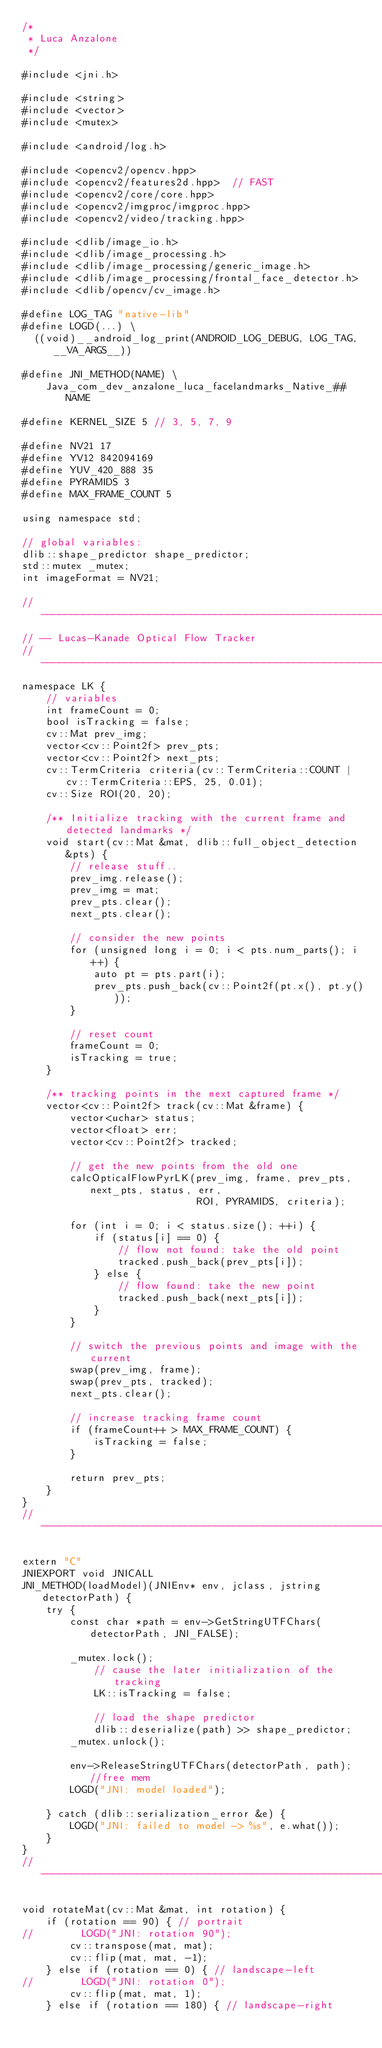Convert code to text. <code><loc_0><loc_0><loc_500><loc_500><_C++_>/*
 * Luca Anzalone
 */

#include <jni.h>

#include <string>
#include <vector>
#include <mutex>

#include <android/log.h>

#include <opencv2/opencv.hpp>
#include <opencv2/features2d.hpp>  // FAST
#include <opencv2/core/core.hpp>
#include <opencv2/imgproc/imgproc.hpp>
#include <opencv2/video/tracking.hpp>

#include <dlib/image_io.h>
#include <dlib/image_processing.h>
#include <dlib/image_processing/generic_image.h>
#include <dlib/image_processing/frontal_face_detector.h>
#include <dlib/opencv/cv_image.h>

#define LOG_TAG "native-lib"
#define LOGD(...) \
  ((void)__android_log_print(ANDROID_LOG_DEBUG, LOG_TAG, __VA_ARGS__))

#define JNI_METHOD(NAME) \
    Java_com_dev_anzalone_luca_facelandmarks_Native_##NAME

#define KERNEL_SIZE 5 // 3, 5, 7, 9

#define NV21 17
#define YV12 842094169
#define YUV_420_888 35
#define PYRAMIDS 3
#define MAX_FRAME_COUNT 5

using namespace std;

// global variables:
dlib::shape_predictor shape_predictor;
std::mutex _mutex;
int imageFormat = NV21;

// -------------------------------------------------------------------------------------------------
// -- Lucas-Kanade Optical Flow Tracker
// -------------------------------------------------------------------------------------------------
namespace LK {
    // variables
    int frameCount = 0;
    bool isTracking = false;
    cv::Mat prev_img;
    vector<cv::Point2f> prev_pts;
    vector<cv::Point2f> next_pts;
    cv::TermCriteria criteria(cv::TermCriteria::COUNT | cv::TermCriteria::EPS, 25, 0.01);
    cv::Size ROI(20, 20);

    /** Initialize tracking with the current frame and detected landmarks */
    void start(cv::Mat &mat, dlib::full_object_detection &pts) {
        // release stuff..
        prev_img.release();
        prev_img = mat;
        prev_pts.clear();
        next_pts.clear();

        // consider the new points
        for (unsigned long i = 0; i < pts.num_parts(); i++) {
            auto pt = pts.part(i);
            prev_pts.push_back(cv::Point2f(pt.x(), pt.y()));
        }

        // reset count
        frameCount = 0;
        isTracking = true;
    }

    /** tracking points in the next captured frame */
    vector<cv::Point2f> track(cv::Mat &frame) {
        vector<uchar> status;
        vector<float> err;
        vector<cv::Point2f> tracked;

        // get the new points from the old one
        calcOpticalFlowPyrLK(prev_img, frame, prev_pts, next_pts, status, err,
                             ROI, PYRAMIDS, criteria);

        for (int i = 0; i < status.size(); ++i) {
            if (status[i] == 0) {
                // flow not found: take the old point
                tracked.push_back(prev_pts[i]);
            } else {
                // flow found: take the new point
                tracked.push_back(next_pts[i]);
            }
        }

        // switch the previous points and image with the current
        swap(prev_img, frame);
        swap(prev_pts, tracked);
        next_pts.clear();

        // increase tracking frame count
        if (frameCount++ > MAX_FRAME_COUNT) {
            isTracking = false;
        }

        return prev_pts;
    }
}
// -------------------------------------------------------------------------------------------------

extern "C"
JNIEXPORT void JNICALL
JNI_METHOD(loadModel)(JNIEnv* env, jclass, jstring detectorPath) {
    try {
        const char *path = env->GetStringUTFChars(detectorPath, JNI_FALSE);

        _mutex.lock();
            // cause the later initialization of the tracking
            LK::isTracking = false;

            // load the shape predictor
            dlib::deserialize(path) >> shape_predictor;
        _mutex.unlock();

        env->ReleaseStringUTFChars(detectorPath, path); //free mem
        LOGD("JNI: model loaded");

    } catch (dlib::serialization_error &e) {
        LOGD("JNI: failed to model -> %s", e.what());
    }
}
//--------------------------------------------------------------------------------------------------

void rotateMat(cv::Mat &mat, int rotation) {
    if (rotation == 90) { // portrait
//        LOGD("JNI: rotation 90");
        cv::transpose(mat, mat);
        cv::flip(mat, mat, -1);
    } else if (rotation == 0) { // landscape-left
//        LOGD("JNI: rotation 0");
        cv::flip(mat, mat, 1);
    } else if (rotation == 180) { // landscape-right</code> 